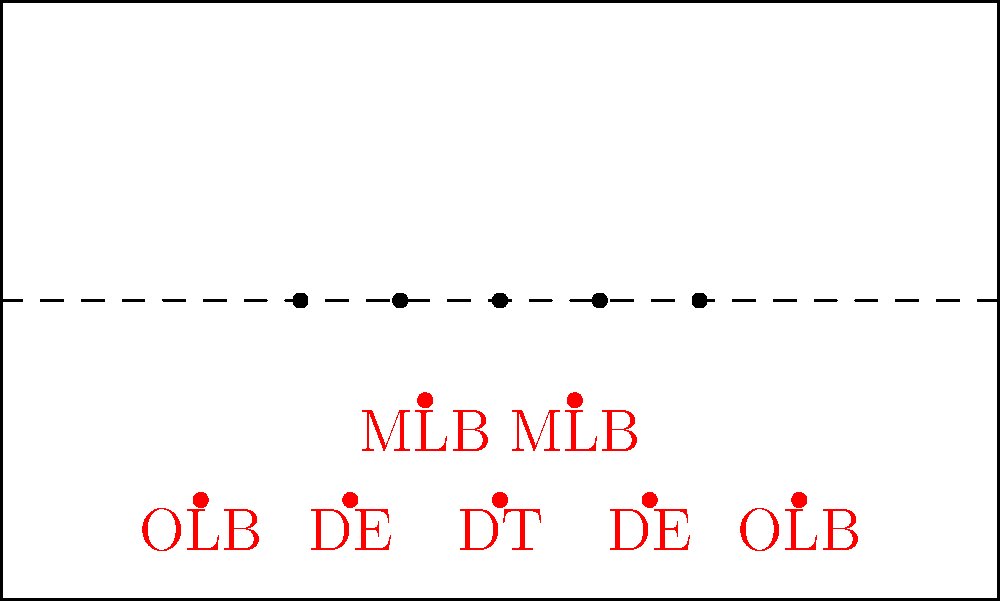Based on the pre-snap alignment diagram shown, which defensive strategy is most likely being employed, and how could a machine learning model be trained to recognize this formation? To identify the defensive strategy and train a machine learning model to recognize this formation, we can follow these steps:

1. Analyze the diagram:
   - We see 7 defensive players in the box (close to the line of scrimmage).
   - There are 2 defensive ends (DE), 1 defensive tackle (DT), 2 outside linebackers (OLB), and 2 middle linebackers (MLB).

2. Identify the formation:
   - This alignment resembles a 3-4 defense (3 linemen, 4 linebackers).
   - The single DT suggests a "Okie" or "30" front variation of the 3-4 defense.

3. Machine learning approach:
   a. Data collection:
      - Gather a large dataset of pre-snap alignment diagrams with labeled defensive strategies.
   b. Feature extraction:
      - Convert diagrams into numerical representations (e.g., player coordinates, distances between players).
   c. Model selection:
      - Choose an appropriate ML algorithm (e.g., Convolutional Neural Network for image classification).
   d. Training:
      - Feed the labeled data into the model, adjusting weights to minimize classification errors.
   e. Validation:
      - Test the model on a separate dataset to ensure accurate predictions.

4. Key features for the model to consider:
   - Number of players on the line of scrimmage
   - Spacing between defensive linemen
   - Positioning of linebackers relative to the line
   - Overall shape of the defensive formation

5. Potential challenges:
   - Variations in 3-4 defenses (e.g., 3-4 Under, 3-4 Over)
   - Disguised coverages or late shifts in alignment
   - Accounting for offensive formation influences on defensive alignment

By training on diverse examples and focusing on these key features, a machine learning model could learn to accurately classify this and other defensive strategies based on pre-snap alignment diagrams.
Answer: 3-4 "Okie" defense; CNN trained on labeled alignment diagrams 